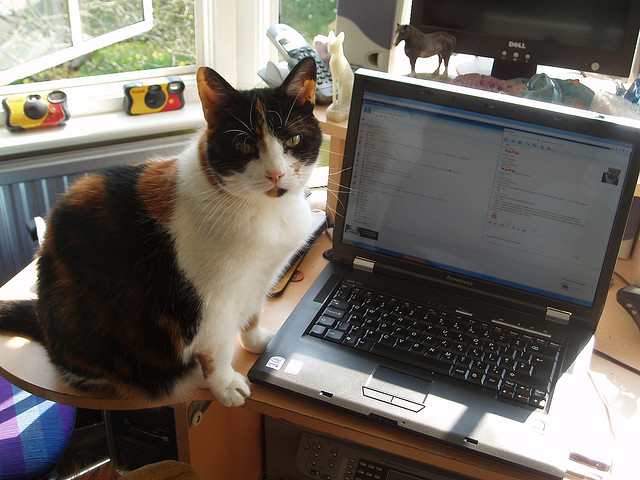Read and extract the text from this image. LENOVO N 